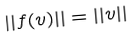<formula> <loc_0><loc_0><loc_500><loc_500>| | f ( v ) | | = | | v | |</formula> 